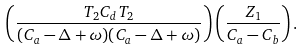<formula> <loc_0><loc_0><loc_500><loc_500>\left ( \frac { T _ { 2 } C _ { d } T _ { 2 } } { ( C _ { a } - \Delta + \omega ) ( C _ { a } - \Delta + \omega ) } \right ) \left ( \frac { Z _ { 1 } } { C _ { a } - C _ { b } } \right ) .</formula> 